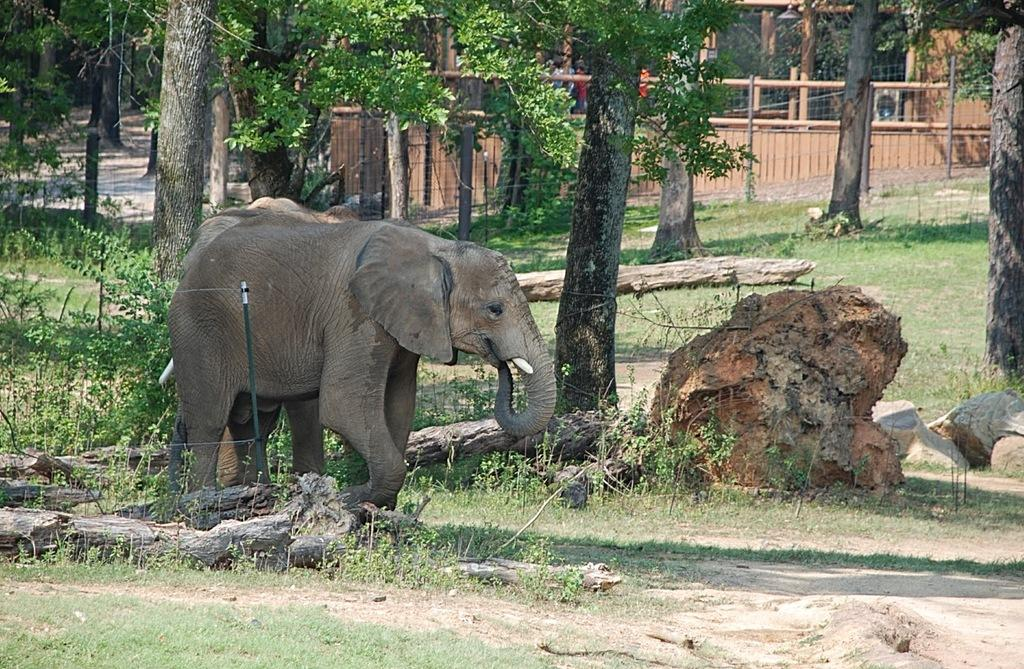What animals are walking on the ground in the image? There are elephants walking on the ground in the image. What type of natural features can be seen in the image? Rocks, plants, and trees are visible in the image. What is in the background of the image? There is a fence and a wooden house in the background of the image. What type of invention is being showcased in the image? There is no invention present in the image; it features elephants walking on the ground, rocks, plants, trees, a fence, and a wooden house. What type of apparel are the elephants wearing in the image? Elephants do not wear apparel, and there are no humans or other animals wearing clothing in the image. 